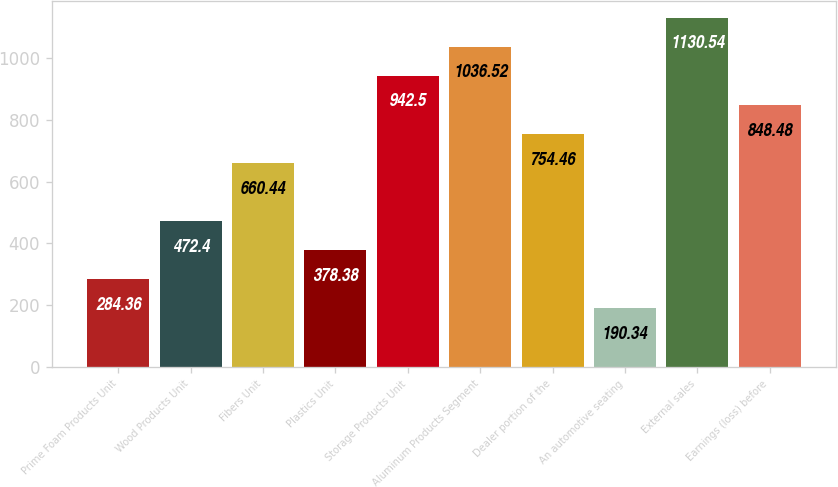Convert chart. <chart><loc_0><loc_0><loc_500><loc_500><bar_chart><fcel>Prime Foam Products Unit<fcel>Wood Products Unit<fcel>Fibers Unit<fcel>Plastics Unit<fcel>Storage Products Unit<fcel>Aluminum Products Segment<fcel>Dealer portion of the<fcel>An automotive seating<fcel>External sales<fcel>Earnings (loss) before<nl><fcel>284.36<fcel>472.4<fcel>660.44<fcel>378.38<fcel>942.5<fcel>1036.52<fcel>754.46<fcel>190.34<fcel>1130.54<fcel>848.48<nl></chart> 